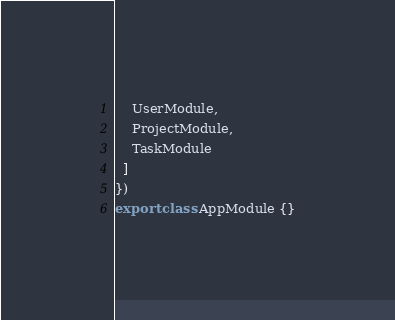<code> <loc_0><loc_0><loc_500><loc_500><_TypeScript_>    UserModule,
    ProjectModule,
    TaskModule
  ]
})
export class AppModule {}
</code> 